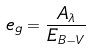Convert formula to latex. <formula><loc_0><loc_0><loc_500><loc_500>e _ { g } = \frac { A _ { \lambda } } { E _ { B - V } }</formula> 